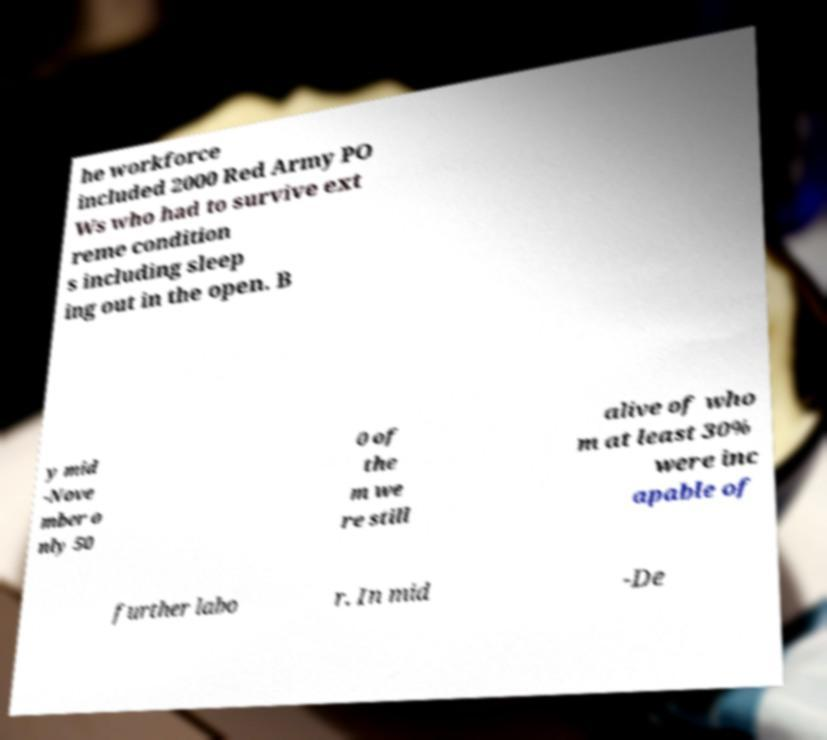What messages or text are displayed in this image? I need them in a readable, typed format. he workforce included 2000 Red Army PO Ws who had to survive ext reme condition s including sleep ing out in the open. B y mid -Nove mber o nly 50 0 of the m we re still alive of who m at least 30% were inc apable of further labo r. In mid -De 